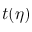Convert formula to latex. <formula><loc_0><loc_0><loc_500><loc_500>t ( \eta )</formula> 